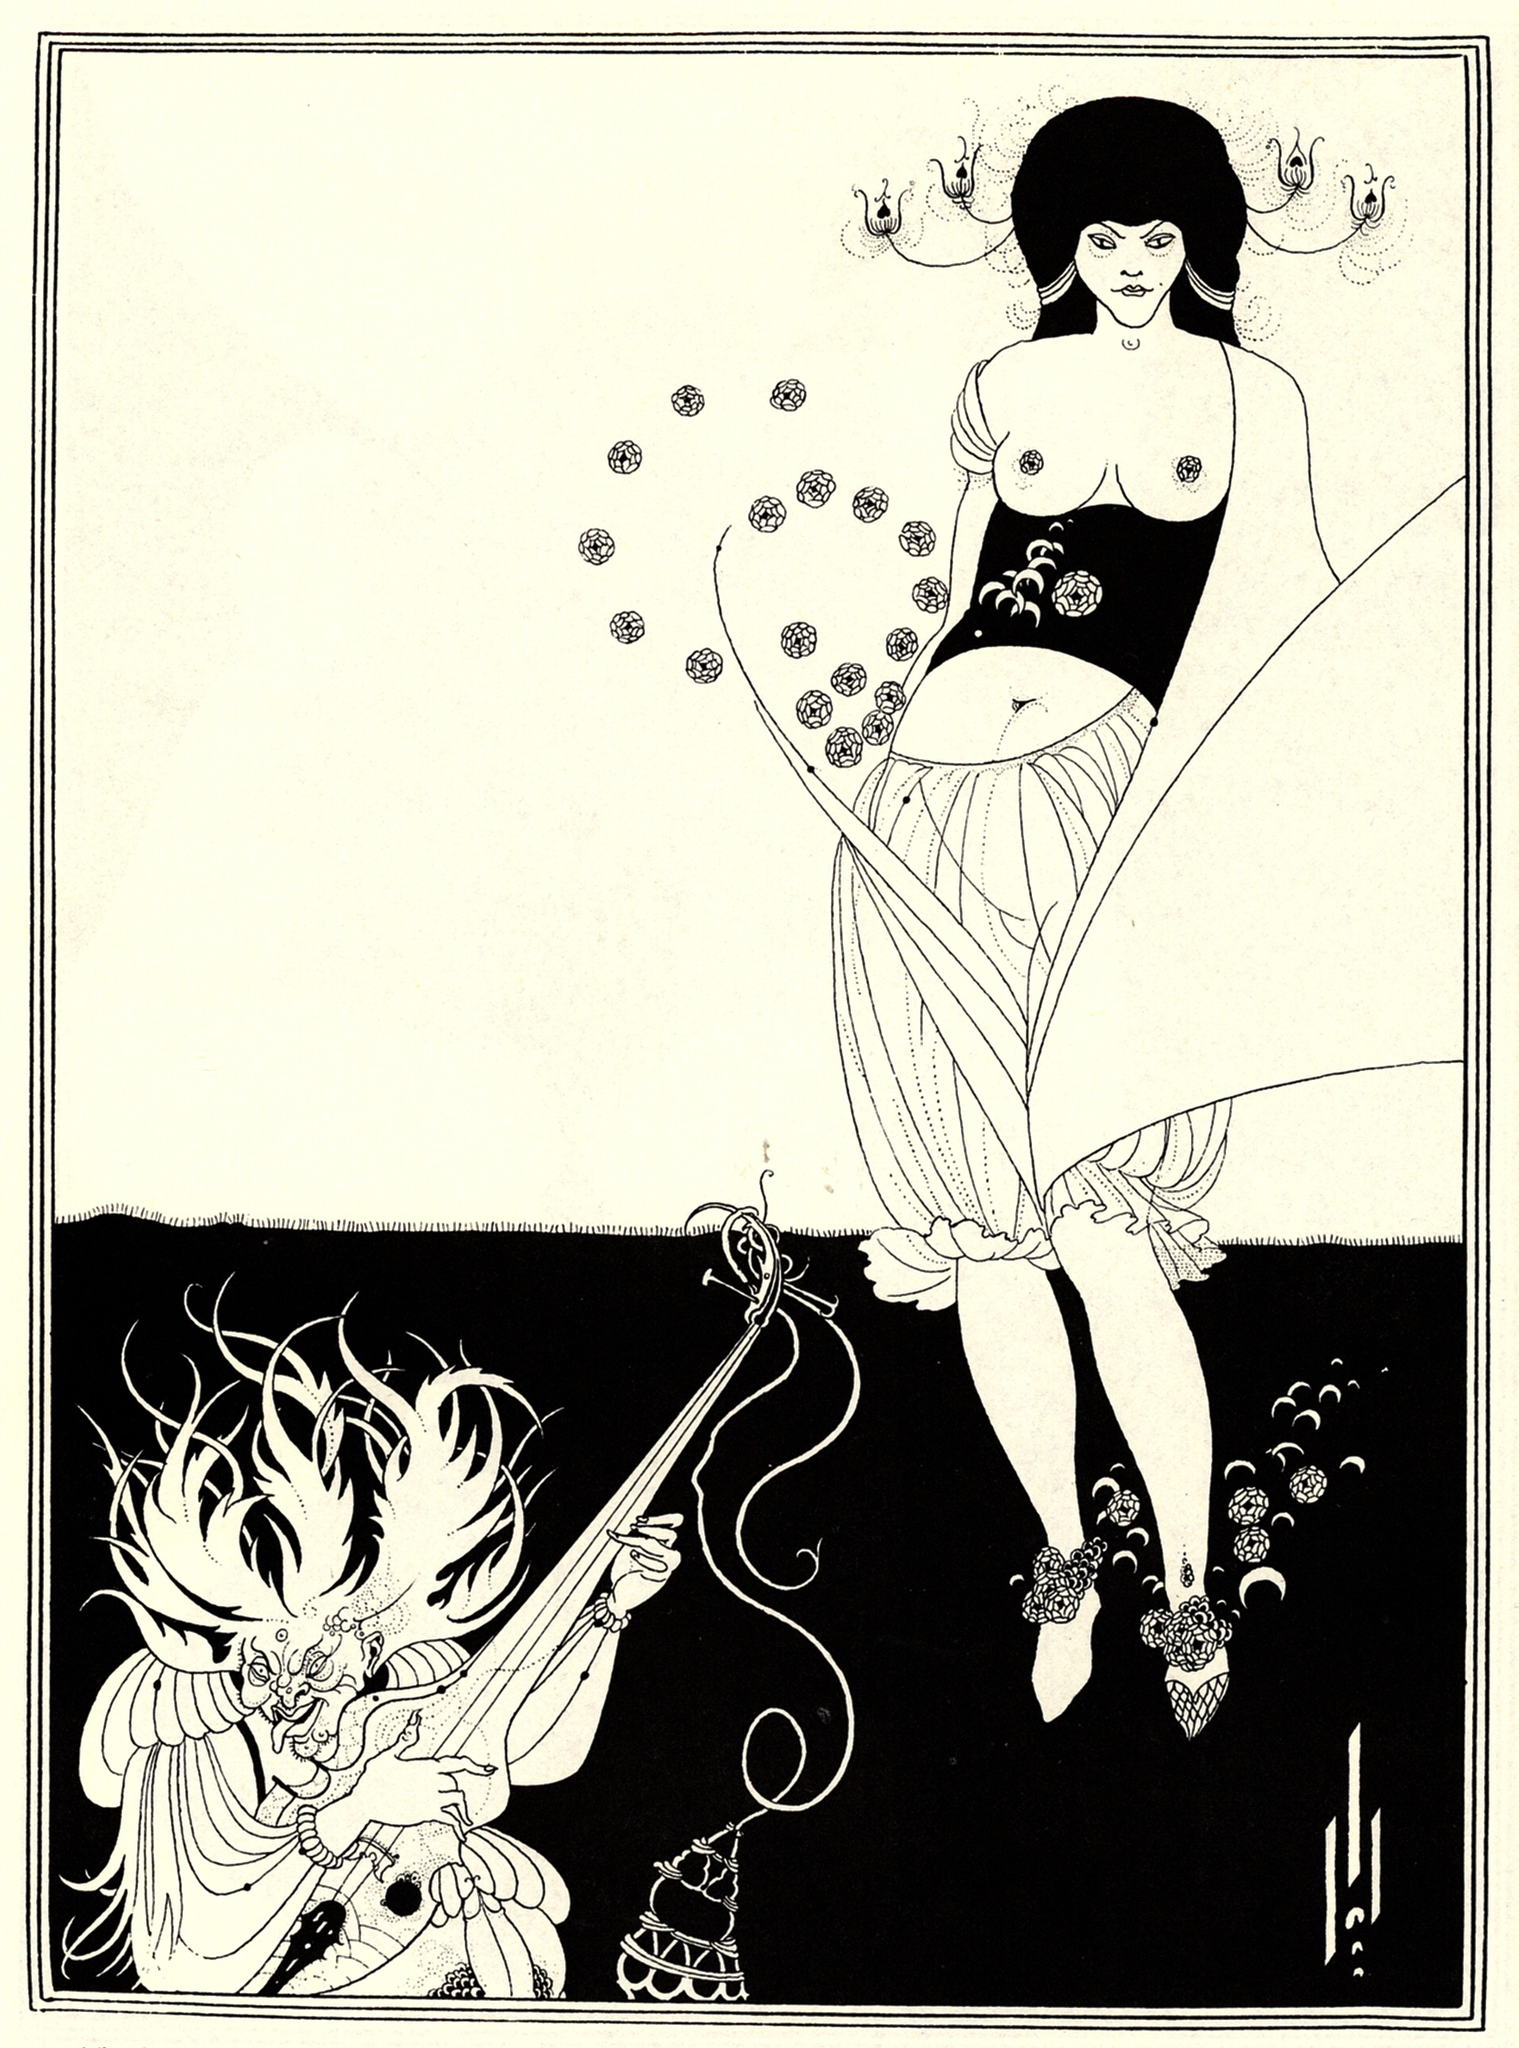Imagine if these characters came to life. What kind of story would unfold? In a fantastical realm where art and reality blur, the woman and dragon in this illustration embark on an epic journey. The woman, a sorceress with a deep connection to nature, wields her magical staff not just as a weapon but as a tool to restore balance between humans and mystical creatures. The dragon, once a fierce guardian of ancient secrets, has chosen to ally with the sorceress in her quest. Together, they face daunting challenges, mystical landscapes, and adversaries who seek to disrupt the harmony they strive to achieve. Their journey teaches them about trust, courage, and the intricate balance between might and magic. 